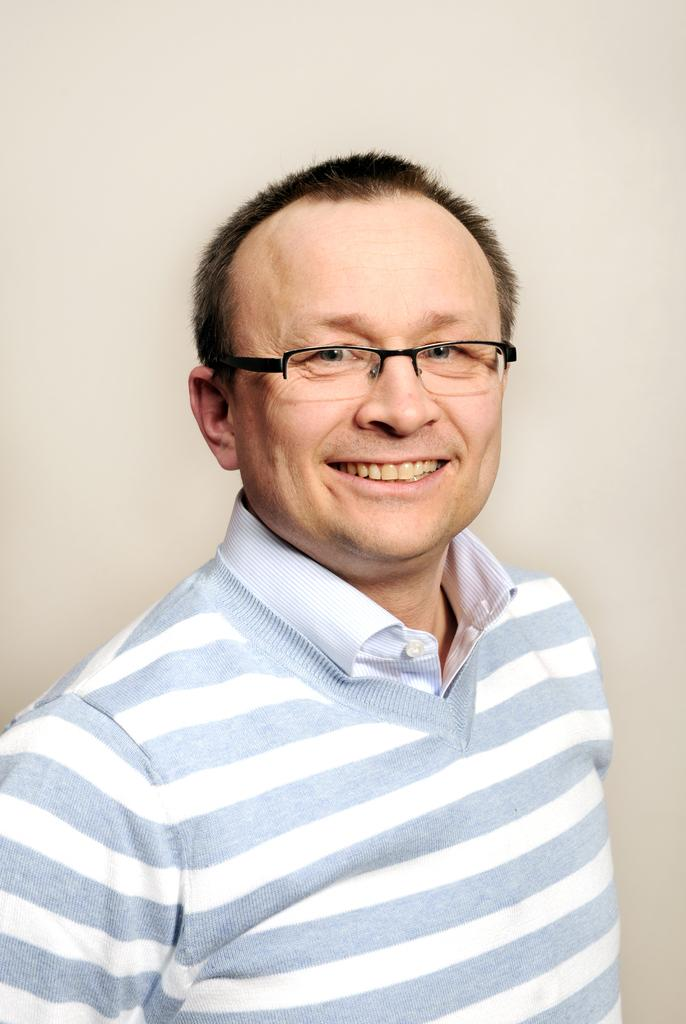Who is the main subject in the image? There is a man in the center of the image. What is the man doing in the image? The man is smiling. What accessory is the man wearing in the image? The man is wearing spectacles. What can be seen in the background of the image? There is a wall in the background of the image. What type of amusement can be seen in the image? There is no amusement present in the image; it features a man smiling and wearing spectacles. Can you tell me how many rats are visible in the image? There are no rats present in the image. 